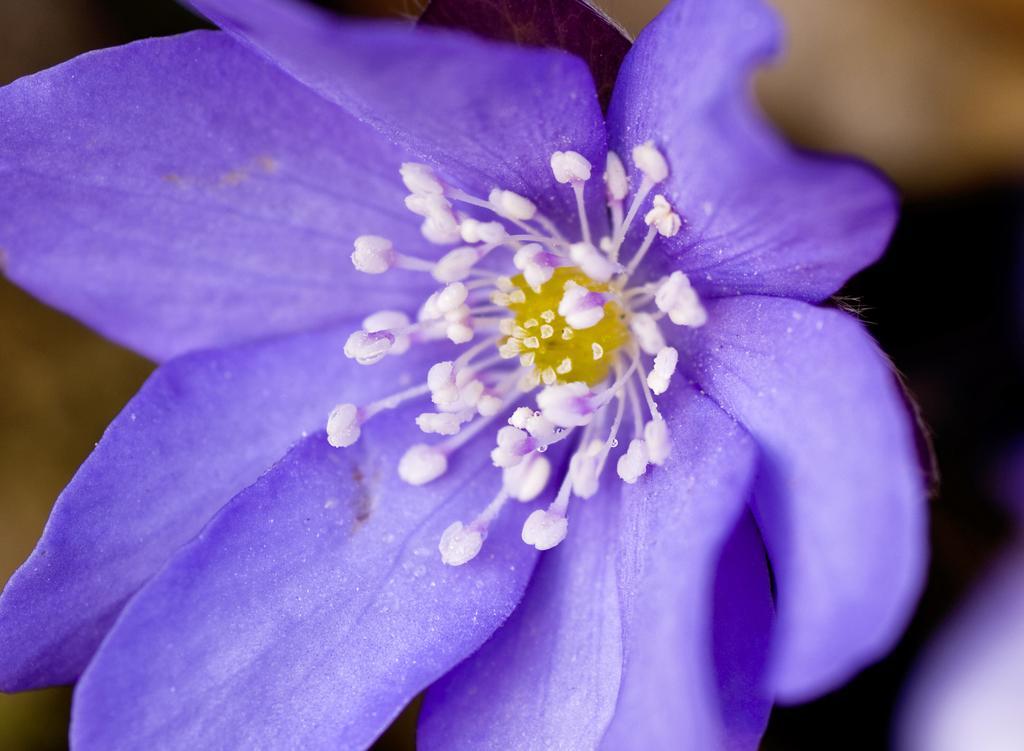Please provide a concise description of this image. In this image we can see a purple color flower and the background is blurred. 